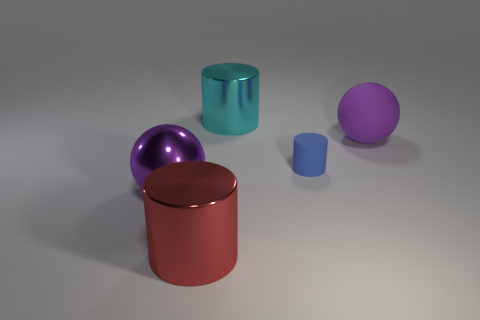Add 5 small blue matte objects. How many objects exist? 10 Subtract all cylinders. How many objects are left? 2 Add 1 cylinders. How many cylinders are left? 4 Add 5 large red cubes. How many large red cubes exist? 5 Subtract 0 green cylinders. How many objects are left? 5 Subtract all tiny red rubber objects. Subtract all tiny things. How many objects are left? 4 